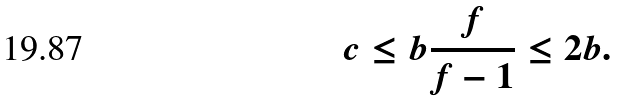<formula> <loc_0><loc_0><loc_500><loc_500>c \leq b \frac { f } { f - 1 } \leq 2 b .</formula> 